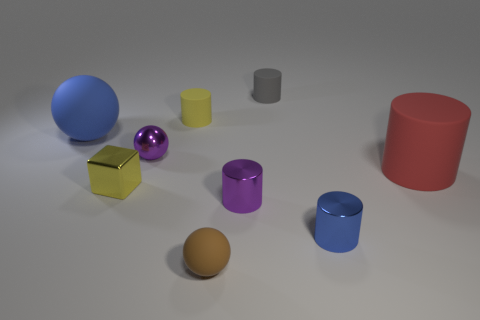What number of purple shiny cylinders have the same size as the blue matte sphere?
Offer a very short reply. 0. Do the matte sphere to the right of the blue rubber sphere and the yellow metal cube in front of the blue ball have the same size?
Provide a short and direct response. Yes. What is the shape of the large object that is in front of the big rubber ball?
Keep it short and to the point. Cylinder. What material is the large object behind the rubber object that is on the right side of the gray thing?
Provide a succinct answer. Rubber. Are there any tiny things that have the same color as the tiny shiny sphere?
Offer a terse response. Yes. There is a brown matte sphere; is its size the same as the matte thing that is to the left of the tiny metallic block?
Keep it short and to the point. No. There is a rubber object that is in front of the large matte thing that is in front of the big matte sphere; how many tiny cylinders are in front of it?
Give a very brief answer. 0. There is a gray cylinder; how many tiny yellow rubber cylinders are in front of it?
Your answer should be compact. 1. There is a tiny metal block behind the small ball that is in front of the big red object; what is its color?
Your answer should be compact. Yellow. How many other things are there of the same material as the brown object?
Keep it short and to the point. 4. 